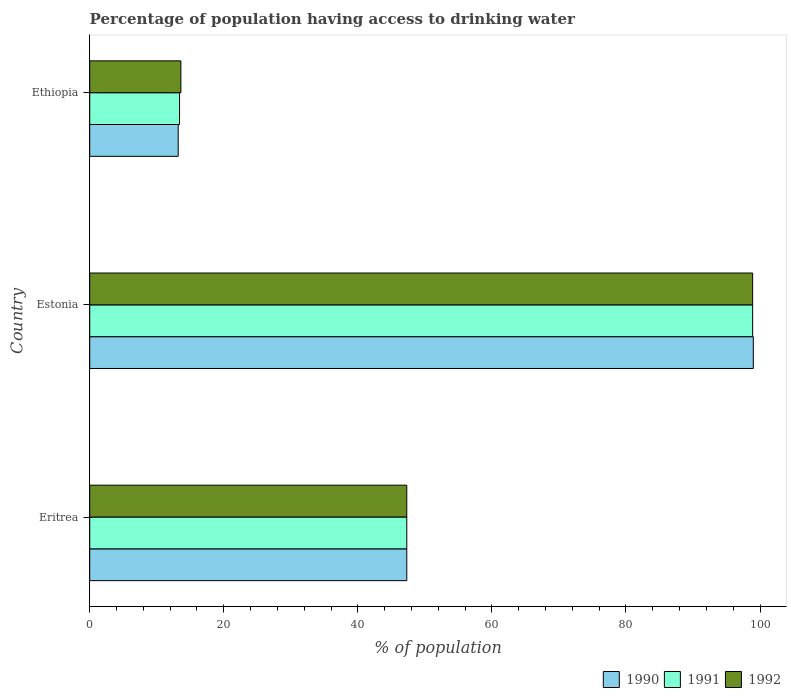How many groups of bars are there?
Make the answer very short. 3. Are the number of bars on each tick of the Y-axis equal?
Give a very brief answer. Yes. How many bars are there on the 2nd tick from the top?
Provide a short and direct response. 3. What is the label of the 2nd group of bars from the top?
Offer a very short reply. Estonia. Across all countries, what is the maximum percentage of population having access to drinking water in 1991?
Provide a succinct answer. 98.9. Across all countries, what is the minimum percentage of population having access to drinking water in 1991?
Keep it short and to the point. 13.4. In which country was the percentage of population having access to drinking water in 1992 maximum?
Give a very brief answer. Estonia. In which country was the percentage of population having access to drinking water in 1990 minimum?
Keep it short and to the point. Ethiopia. What is the total percentage of population having access to drinking water in 1991 in the graph?
Keep it short and to the point. 159.6. What is the difference between the percentage of population having access to drinking water in 1992 in Eritrea and that in Ethiopia?
Ensure brevity in your answer.  33.7. What is the difference between the percentage of population having access to drinking water in 1992 in Eritrea and the percentage of population having access to drinking water in 1991 in Estonia?
Make the answer very short. -51.6. What is the average percentage of population having access to drinking water in 1992 per country?
Your response must be concise. 53.27. In how many countries, is the percentage of population having access to drinking water in 1990 greater than 44 %?
Make the answer very short. 2. What is the ratio of the percentage of population having access to drinking water in 1992 in Eritrea to that in Estonia?
Make the answer very short. 0.48. Is the percentage of population having access to drinking water in 1990 in Eritrea less than that in Estonia?
Provide a short and direct response. Yes. Is the difference between the percentage of population having access to drinking water in 1991 in Eritrea and Estonia greater than the difference between the percentage of population having access to drinking water in 1990 in Eritrea and Estonia?
Keep it short and to the point. Yes. What is the difference between the highest and the second highest percentage of population having access to drinking water in 1990?
Provide a short and direct response. 51.7. What is the difference between the highest and the lowest percentage of population having access to drinking water in 1992?
Give a very brief answer. 85.3. In how many countries, is the percentage of population having access to drinking water in 1991 greater than the average percentage of population having access to drinking water in 1991 taken over all countries?
Your answer should be compact. 1. What does the 2nd bar from the bottom in Estonia represents?
Offer a very short reply. 1991. Are all the bars in the graph horizontal?
Give a very brief answer. Yes. How many countries are there in the graph?
Offer a terse response. 3. Does the graph contain grids?
Make the answer very short. No. How many legend labels are there?
Give a very brief answer. 3. What is the title of the graph?
Make the answer very short. Percentage of population having access to drinking water. What is the label or title of the X-axis?
Your answer should be very brief. % of population. What is the label or title of the Y-axis?
Offer a very short reply. Country. What is the % of population in 1990 in Eritrea?
Make the answer very short. 47.3. What is the % of population in 1991 in Eritrea?
Make the answer very short. 47.3. What is the % of population in 1992 in Eritrea?
Offer a terse response. 47.3. What is the % of population of 1990 in Estonia?
Offer a terse response. 99. What is the % of population of 1991 in Estonia?
Your answer should be compact. 98.9. What is the % of population of 1992 in Estonia?
Your answer should be compact. 98.9. What is the % of population in 1991 in Ethiopia?
Provide a succinct answer. 13.4. What is the % of population of 1992 in Ethiopia?
Give a very brief answer. 13.6. Across all countries, what is the maximum % of population in 1991?
Your answer should be compact. 98.9. Across all countries, what is the maximum % of population in 1992?
Offer a very short reply. 98.9. Across all countries, what is the minimum % of population of 1990?
Provide a short and direct response. 13.2. What is the total % of population in 1990 in the graph?
Provide a short and direct response. 159.5. What is the total % of population in 1991 in the graph?
Offer a terse response. 159.6. What is the total % of population of 1992 in the graph?
Ensure brevity in your answer.  159.8. What is the difference between the % of population of 1990 in Eritrea and that in Estonia?
Give a very brief answer. -51.7. What is the difference between the % of population of 1991 in Eritrea and that in Estonia?
Your response must be concise. -51.6. What is the difference between the % of population of 1992 in Eritrea and that in Estonia?
Your answer should be compact. -51.6. What is the difference between the % of population in 1990 in Eritrea and that in Ethiopia?
Keep it short and to the point. 34.1. What is the difference between the % of population of 1991 in Eritrea and that in Ethiopia?
Provide a short and direct response. 33.9. What is the difference between the % of population in 1992 in Eritrea and that in Ethiopia?
Keep it short and to the point. 33.7. What is the difference between the % of population of 1990 in Estonia and that in Ethiopia?
Provide a short and direct response. 85.8. What is the difference between the % of population of 1991 in Estonia and that in Ethiopia?
Your answer should be very brief. 85.5. What is the difference between the % of population in 1992 in Estonia and that in Ethiopia?
Ensure brevity in your answer.  85.3. What is the difference between the % of population of 1990 in Eritrea and the % of population of 1991 in Estonia?
Ensure brevity in your answer.  -51.6. What is the difference between the % of population of 1990 in Eritrea and the % of population of 1992 in Estonia?
Your response must be concise. -51.6. What is the difference between the % of population of 1991 in Eritrea and the % of population of 1992 in Estonia?
Your answer should be compact. -51.6. What is the difference between the % of population of 1990 in Eritrea and the % of population of 1991 in Ethiopia?
Offer a very short reply. 33.9. What is the difference between the % of population of 1990 in Eritrea and the % of population of 1992 in Ethiopia?
Offer a very short reply. 33.7. What is the difference between the % of population of 1991 in Eritrea and the % of population of 1992 in Ethiopia?
Provide a succinct answer. 33.7. What is the difference between the % of population in 1990 in Estonia and the % of population in 1991 in Ethiopia?
Keep it short and to the point. 85.6. What is the difference between the % of population in 1990 in Estonia and the % of population in 1992 in Ethiopia?
Offer a very short reply. 85.4. What is the difference between the % of population in 1991 in Estonia and the % of population in 1992 in Ethiopia?
Keep it short and to the point. 85.3. What is the average % of population of 1990 per country?
Provide a succinct answer. 53.17. What is the average % of population of 1991 per country?
Your answer should be compact. 53.2. What is the average % of population of 1992 per country?
Provide a succinct answer. 53.27. What is the difference between the % of population in 1990 and % of population in 1991 in Eritrea?
Make the answer very short. 0. What is the difference between the % of population in 1990 and % of population in 1992 in Eritrea?
Offer a very short reply. 0. What is the difference between the % of population of 1990 and % of population of 1992 in Estonia?
Your answer should be very brief. 0.1. What is the difference between the % of population of 1990 and % of population of 1991 in Ethiopia?
Give a very brief answer. -0.2. What is the difference between the % of population in 1990 and % of population in 1992 in Ethiopia?
Keep it short and to the point. -0.4. What is the difference between the % of population of 1991 and % of population of 1992 in Ethiopia?
Offer a terse response. -0.2. What is the ratio of the % of population of 1990 in Eritrea to that in Estonia?
Offer a terse response. 0.48. What is the ratio of the % of population in 1991 in Eritrea to that in Estonia?
Ensure brevity in your answer.  0.48. What is the ratio of the % of population in 1992 in Eritrea to that in Estonia?
Ensure brevity in your answer.  0.48. What is the ratio of the % of population of 1990 in Eritrea to that in Ethiopia?
Give a very brief answer. 3.58. What is the ratio of the % of population of 1991 in Eritrea to that in Ethiopia?
Your answer should be compact. 3.53. What is the ratio of the % of population of 1992 in Eritrea to that in Ethiopia?
Your answer should be very brief. 3.48. What is the ratio of the % of population in 1990 in Estonia to that in Ethiopia?
Provide a succinct answer. 7.5. What is the ratio of the % of population of 1991 in Estonia to that in Ethiopia?
Keep it short and to the point. 7.38. What is the ratio of the % of population in 1992 in Estonia to that in Ethiopia?
Provide a short and direct response. 7.27. What is the difference between the highest and the second highest % of population in 1990?
Offer a very short reply. 51.7. What is the difference between the highest and the second highest % of population of 1991?
Offer a terse response. 51.6. What is the difference between the highest and the second highest % of population of 1992?
Give a very brief answer. 51.6. What is the difference between the highest and the lowest % of population of 1990?
Provide a succinct answer. 85.8. What is the difference between the highest and the lowest % of population in 1991?
Your answer should be very brief. 85.5. What is the difference between the highest and the lowest % of population of 1992?
Make the answer very short. 85.3. 